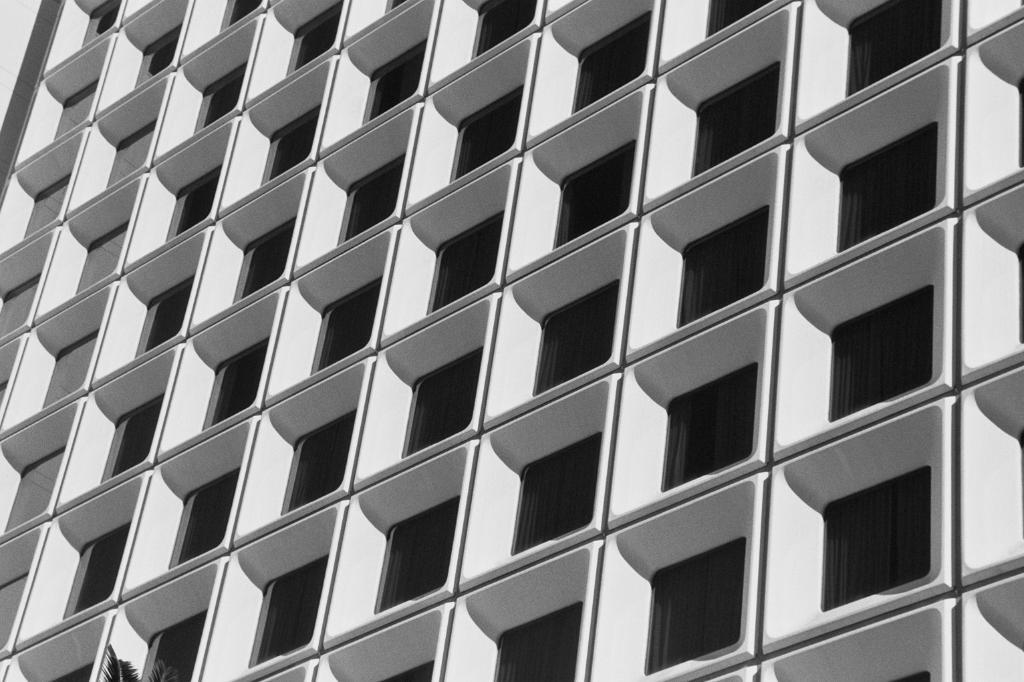What type of structure is present in the image? There is a building in the image. What feature can be seen on the building? The building has windows. What natural element is visible at the bottom of the image? There are leaves of a tree visible at the bottom of the image. What type of committee is meeting in the building in the image? There is no indication of a committee meeting in the building in the image. 